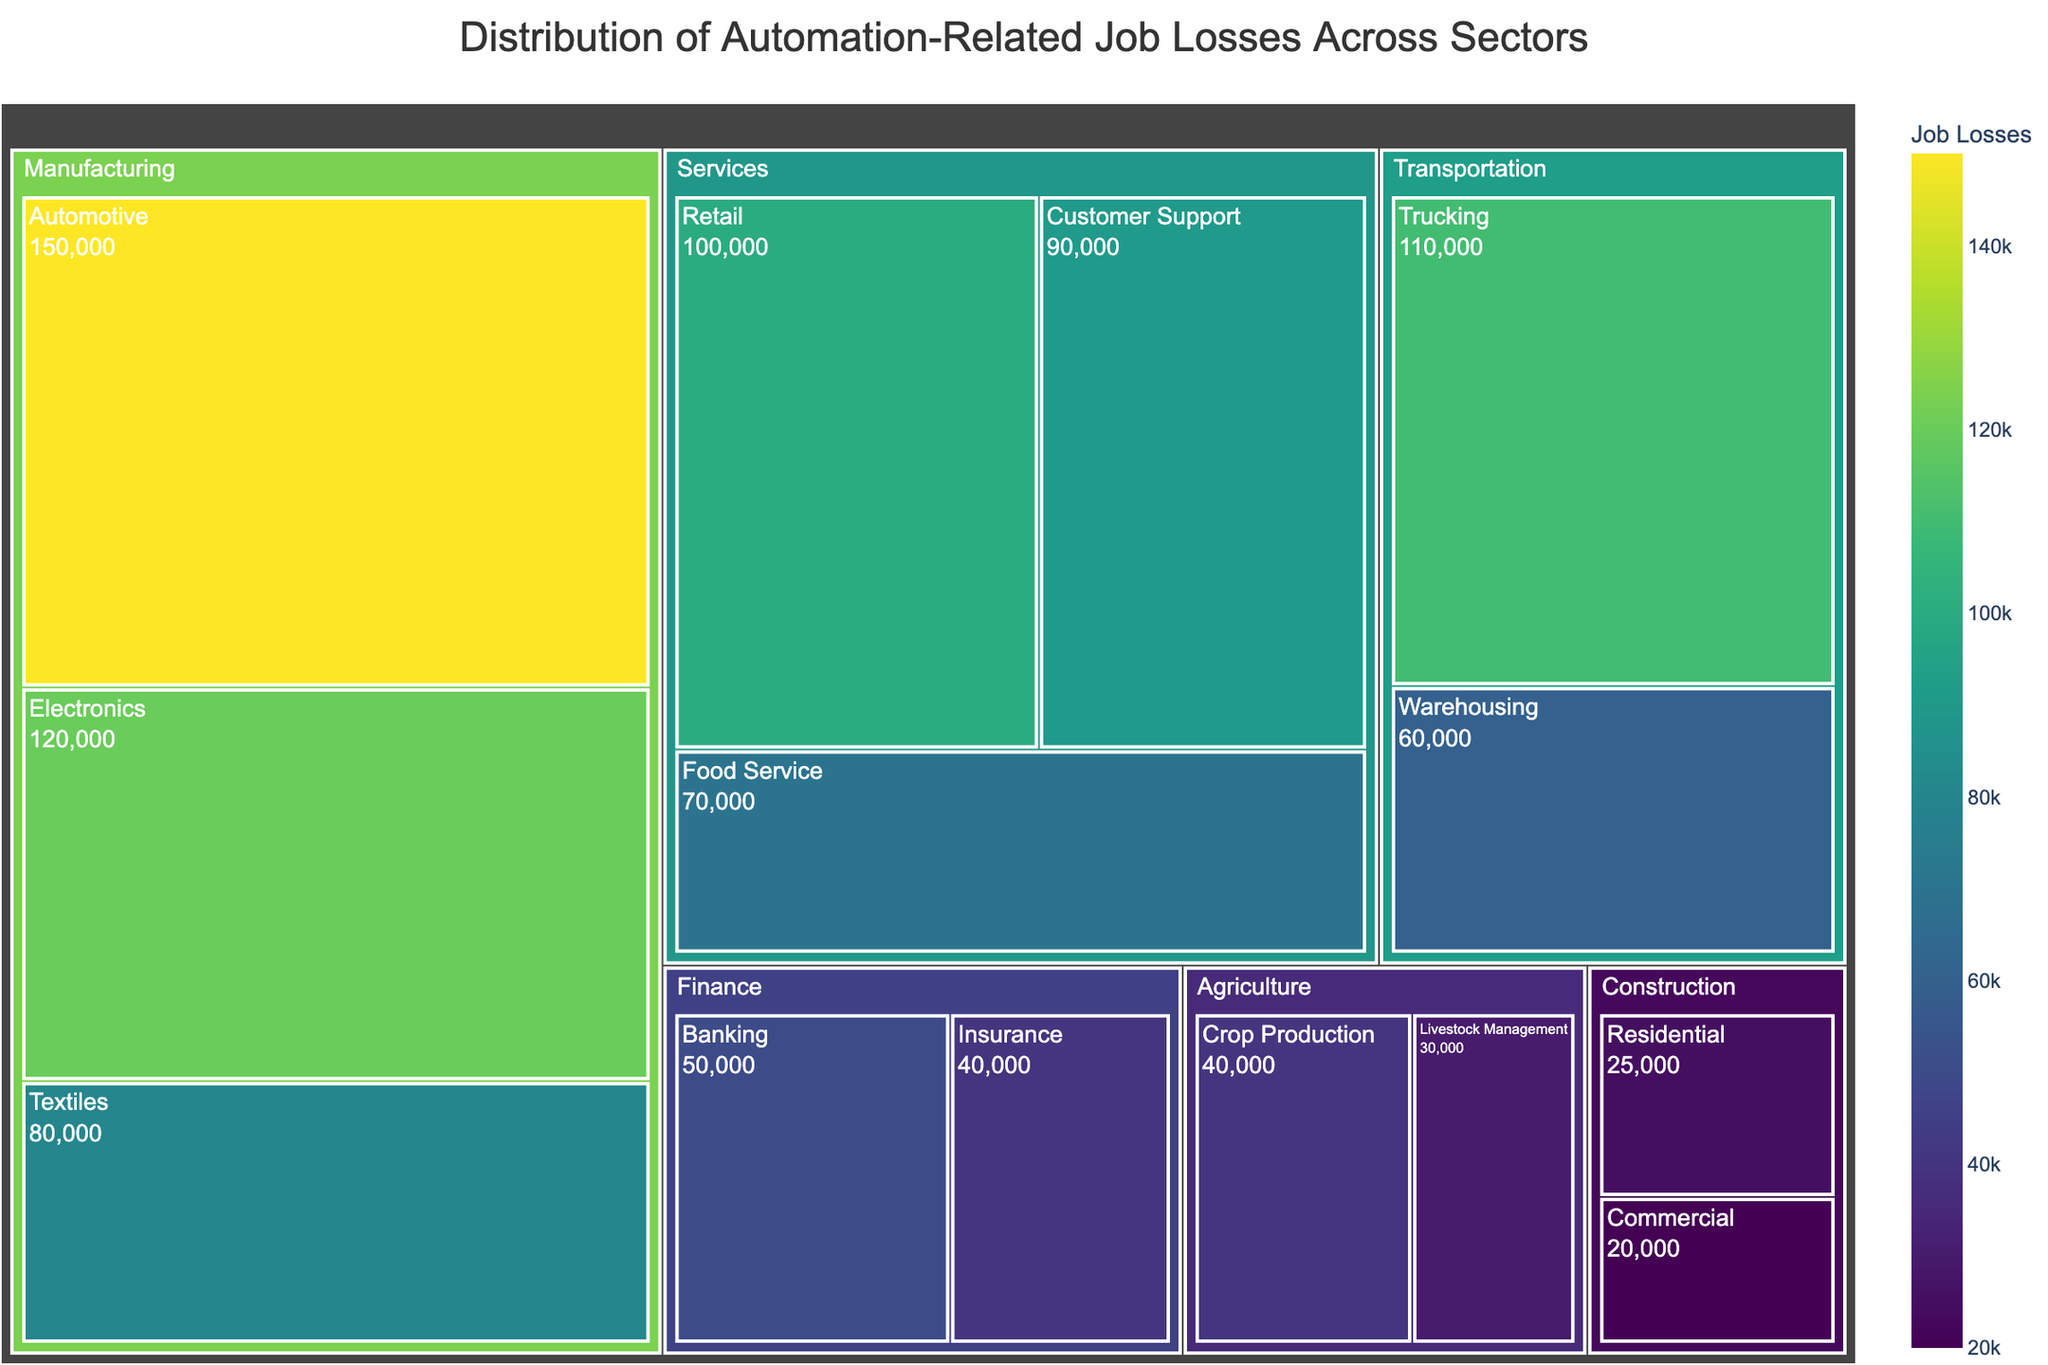What is the title of the figure? The title is usually displayed at the top of the treemap and provides a summary of what the figure is about. Here, it is "Distribution of Automation-Related Job Losses Across Sectors".
Answer: Distribution of Automation-Related Job Losses Across Sectors Which sector has the highest job losses? By looking at the size of the tiles in the treemap, the "Manufacturing" sector appears to have the largest tiles overall, indicating the highest job losses.
Answer: Manufacturing How many job losses are in the retail industry? The retail industry's tile within the "Services" sector shows the job losses number. It's labeled with "100,000".
Answer: 100,000 What is the total number of job losses in the transportation sector? The sum of job losses from "Trucking" and "Warehousing" within the Transportation sector can be calculated. Trucking is 110,000 and Warehousing is 60,000. 110,000 + 60,000 = 170,000.
Answer: 170,000 Which industry in the agricultural sector has fewer job losses, and by how much? The "Crop Production" and "Livestock Management" industries are part of the Agriculture sector. Crop Production has 40,000 job losses, while Livestock Management has 30,000 job losses. The difference is 40,000 - 30,000 = 10,000.
Answer: Livestock Management, by 10,000 What is the color scheme used in the treemap? Observing the figure, it uses a continuous color scale that varies between shades, typically from lighter to darker colors, using a "Viridis" color scheme. This can be seen where the color intensity represents the count of job losses.
Answer: Viridis Which sector has more automation-related job losses, Finance or Construction? By comparing the sizes of the tiles and the labeled job losses, Finance has Banking (50,000) and Insurance (40,000), totaling to 90,000; while Construction has Residential (25,000) and Commercial (20,000), totaling to 45,000. 90,000 (Finance) > 45,000 (Construction).
Answer: Finance What is the average job loss for the industries in the Services sector? The industries in Services are Retail (100,000), Customer Support (90,000), and Food Service (70,000). The average can be calculated as (100,000 + 90,000 + 70,000) / 3 = 260,000 / 3 = ~86,667.
Answer: ~86,667 Which industry within the Manufacturing sector has the least job losses? Within the Manufacturing sector, the job losses can be compared across the listed industries: Automotive (150,000), Electronics (120,000), and Textiles (80,000). Textiles has the least with 80,000.
Answer: Textiles How many job losses are there in the Finance and Services sectors combined? The job losses in the Finance sector are Banking (50,000) and Insurance (40,000), totaling to 90,000. In the Services sector, the total is Retail (100,000), Customer Support (90,000), and Food Service (70,000), totaling to 260,000. Combined total is 90,000 + 260,000 = 350,000.
Answer: 350,000 